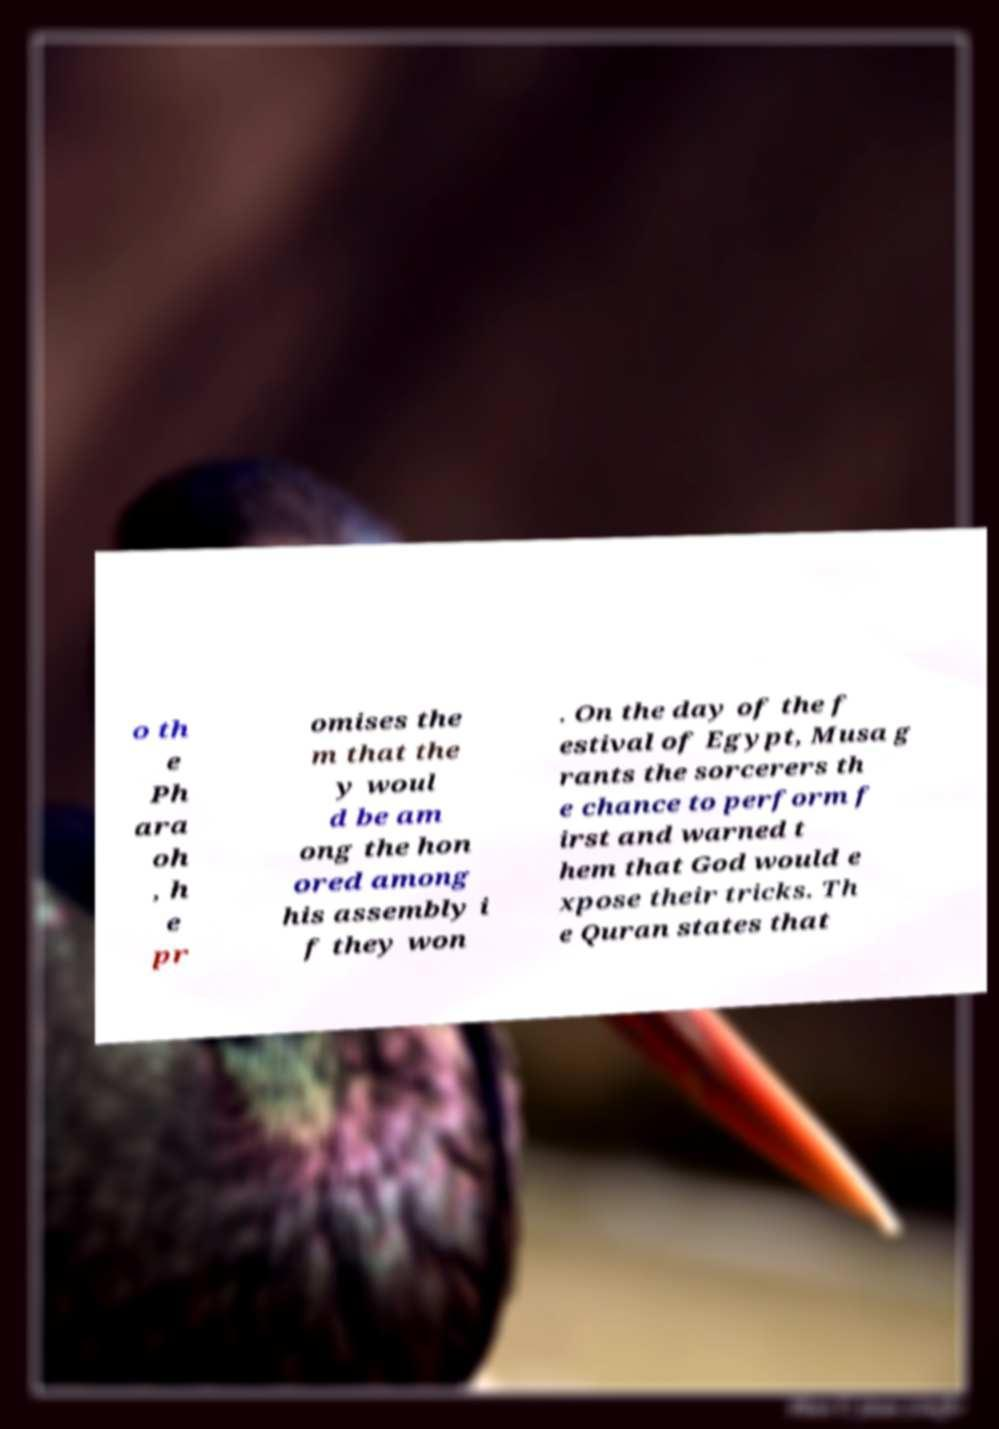Could you assist in decoding the text presented in this image and type it out clearly? o th e Ph ara oh , h e pr omises the m that the y woul d be am ong the hon ored among his assembly i f they won . On the day of the f estival of Egypt, Musa g rants the sorcerers th e chance to perform f irst and warned t hem that God would e xpose their tricks. Th e Quran states that 